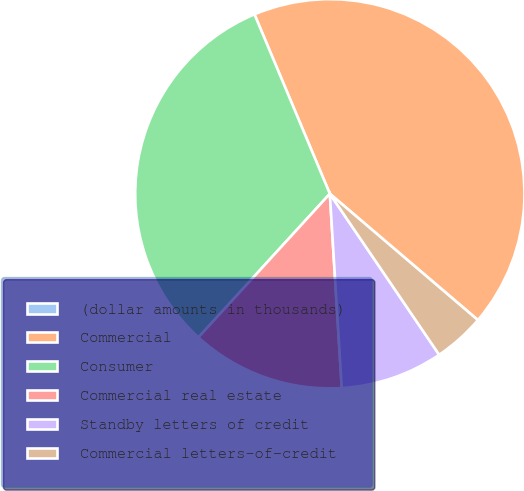<chart> <loc_0><loc_0><loc_500><loc_500><pie_chart><fcel>(dollar amounts in thousands)<fcel>Commercial<fcel>Consumer<fcel>Commercial real estate<fcel>Standby letters of credit<fcel>Commercial letters-of-credit<nl><fcel>0.01%<fcel>42.56%<fcel>31.87%<fcel>12.77%<fcel>8.52%<fcel>4.26%<nl></chart> 